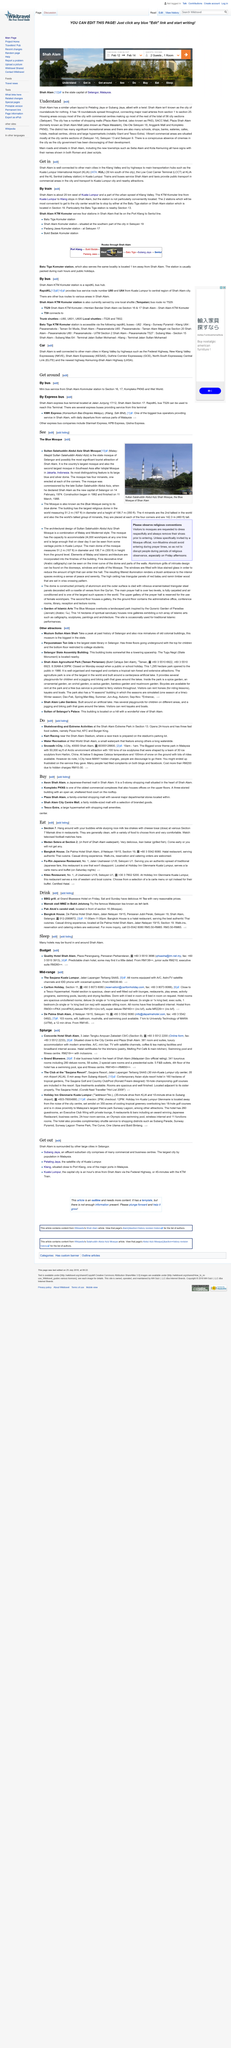Mention a couple of crucial points in this snapshot. The title of this page is Understand. Shah Alam is affectionately referred to as the City of Roundabouts. Shah Alam is the main location mentioned. 